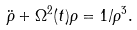<formula> <loc_0><loc_0><loc_500><loc_500>\ddot { \rho } + \Omega ^ { 2 } ( t ) \rho = 1 / \rho ^ { 3 } .</formula> 